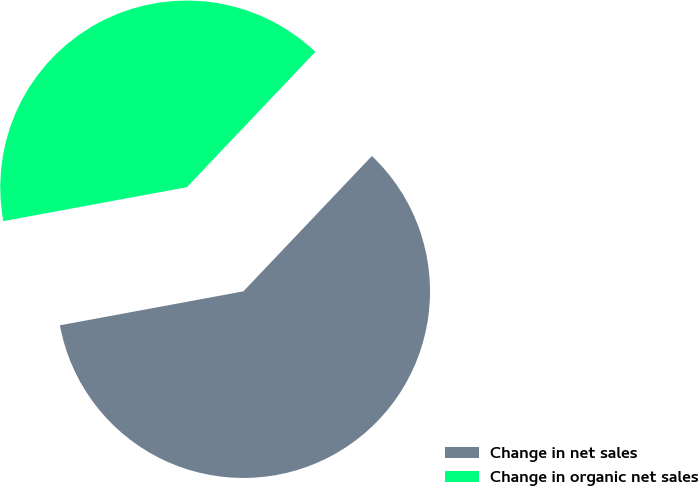Convert chart to OTSL. <chart><loc_0><loc_0><loc_500><loc_500><pie_chart><fcel>Change in net sales<fcel>Change in organic net sales<nl><fcel>60.0%<fcel>40.0%<nl></chart> 